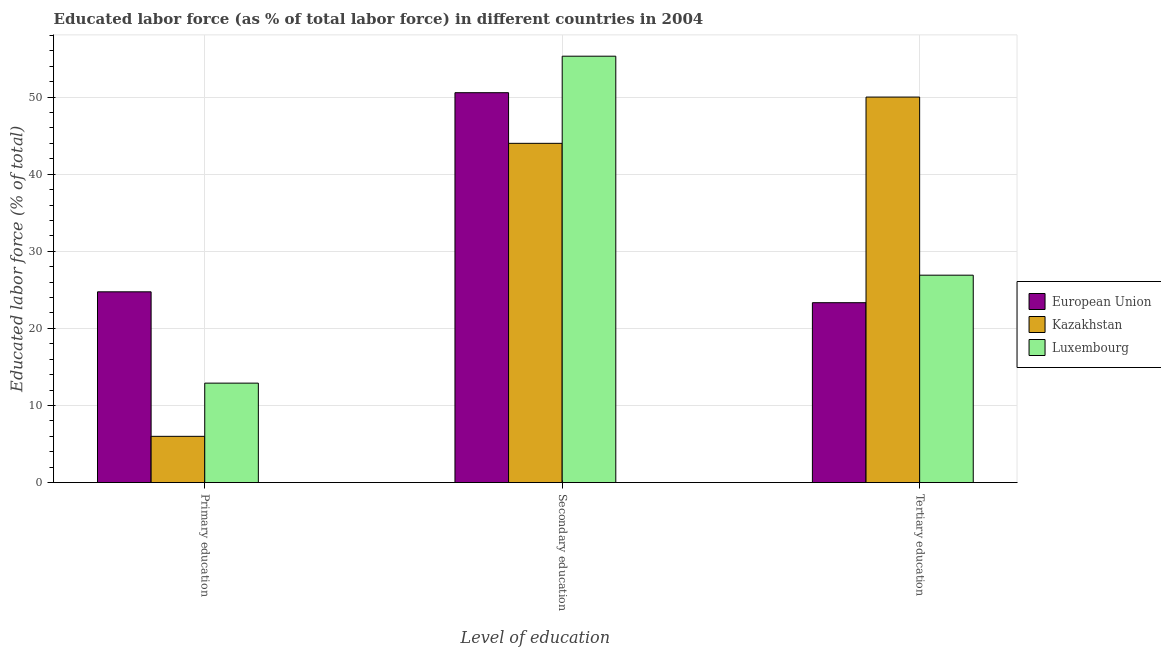How many groups of bars are there?
Offer a terse response. 3. Are the number of bars per tick equal to the number of legend labels?
Ensure brevity in your answer.  Yes. How many bars are there on the 1st tick from the right?
Provide a succinct answer. 3. What is the label of the 3rd group of bars from the left?
Keep it short and to the point. Tertiary education. Across all countries, what is the maximum percentage of labor force who received secondary education?
Make the answer very short. 55.3. Across all countries, what is the minimum percentage of labor force who received primary education?
Your answer should be compact. 6. What is the total percentage of labor force who received tertiary education in the graph?
Your response must be concise. 100.23. What is the difference between the percentage of labor force who received secondary education in European Union and that in Kazakhstan?
Provide a succinct answer. 6.57. What is the difference between the percentage of labor force who received tertiary education in Luxembourg and the percentage of labor force who received secondary education in Kazakhstan?
Offer a very short reply. -17.1. What is the average percentage of labor force who received tertiary education per country?
Your answer should be compact. 33.41. In how many countries, is the percentage of labor force who received tertiary education greater than 52 %?
Provide a succinct answer. 0. What is the ratio of the percentage of labor force who received secondary education in European Union to that in Kazakhstan?
Your answer should be very brief. 1.15. What is the difference between the highest and the second highest percentage of labor force who received primary education?
Make the answer very short. 11.84. What is the difference between the highest and the lowest percentage of labor force who received tertiary education?
Give a very brief answer. 26.67. What does the 3rd bar from the left in Tertiary education represents?
Provide a succinct answer. Luxembourg. What does the 1st bar from the right in Tertiary education represents?
Offer a terse response. Luxembourg. Is it the case that in every country, the sum of the percentage of labor force who received primary education and percentage of labor force who received secondary education is greater than the percentage of labor force who received tertiary education?
Your response must be concise. No. Are all the bars in the graph horizontal?
Provide a succinct answer. No. How many countries are there in the graph?
Offer a terse response. 3. Does the graph contain grids?
Keep it short and to the point. Yes. Where does the legend appear in the graph?
Provide a succinct answer. Center right. How are the legend labels stacked?
Ensure brevity in your answer.  Vertical. What is the title of the graph?
Your answer should be very brief. Educated labor force (as % of total labor force) in different countries in 2004. What is the label or title of the X-axis?
Your answer should be compact. Level of education. What is the label or title of the Y-axis?
Your response must be concise. Educated labor force (% of total). What is the Educated labor force (% of total) in European Union in Primary education?
Your answer should be very brief. 24.74. What is the Educated labor force (% of total) of Luxembourg in Primary education?
Ensure brevity in your answer.  12.9. What is the Educated labor force (% of total) of European Union in Secondary education?
Your response must be concise. 50.57. What is the Educated labor force (% of total) of Luxembourg in Secondary education?
Provide a short and direct response. 55.3. What is the Educated labor force (% of total) of European Union in Tertiary education?
Provide a succinct answer. 23.33. What is the Educated labor force (% of total) in Luxembourg in Tertiary education?
Your answer should be compact. 26.9. Across all Level of education, what is the maximum Educated labor force (% of total) in European Union?
Make the answer very short. 50.57. Across all Level of education, what is the maximum Educated labor force (% of total) in Kazakhstan?
Your answer should be compact. 50. Across all Level of education, what is the maximum Educated labor force (% of total) of Luxembourg?
Give a very brief answer. 55.3. Across all Level of education, what is the minimum Educated labor force (% of total) in European Union?
Your answer should be very brief. 23.33. Across all Level of education, what is the minimum Educated labor force (% of total) in Kazakhstan?
Give a very brief answer. 6. Across all Level of education, what is the minimum Educated labor force (% of total) in Luxembourg?
Ensure brevity in your answer.  12.9. What is the total Educated labor force (% of total) in European Union in the graph?
Offer a very short reply. 98.64. What is the total Educated labor force (% of total) in Luxembourg in the graph?
Offer a very short reply. 95.1. What is the difference between the Educated labor force (% of total) in European Union in Primary education and that in Secondary education?
Offer a terse response. -25.82. What is the difference between the Educated labor force (% of total) in Kazakhstan in Primary education and that in Secondary education?
Offer a very short reply. -38. What is the difference between the Educated labor force (% of total) of Luxembourg in Primary education and that in Secondary education?
Make the answer very short. -42.4. What is the difference between the Educated labor force (% of total) in European Union in Primary education and that in Tertiary education?
Your answer should be compact. 1.41. What is the difference between the Educated labor force (% of total) of Kazakhstan in Primary education and that in Tertiary education?
Offer a terse response. -44. What is the difference between the Educated labor force (% of total) in Luxembourg in Primary education and that in Tertiary education?
Your answer should be very brief. -14. What is the difference between the Educated labor force (% of total) of European Union in Secondary education and that in Tertiary education?
Provide a succinct answer. 27.23. What is the difference between the Educated labor force (% of total) of Kazakhstan in Secondary education and that in Tertiary education?
Keep it short and to the point. -6. What is the difference between the Educated labor force (% of total) in Luxembourg in Secondary education and that in Tertiary education?
Offer a very short reply. 28.4. What is the difference between the Educated labor force (% of total) of European Union in Primary education and the Educated labor force (% of total) of Kazakhstan in Secondary education?
Make the answer very short. -19.26. What is the difference between the Educated labor force (% of total) in European Union in Primary education and the Educated labor force (% of total) in Luxembourg in Secondary education?
Your answer should be very brief. -30.56. What is the difference between the Educated labor force (% of total) in Kazakhstan in Primary education and the Educated labor force (% of total) in Luxembourg in Secondary education?
Provide a short and direct response. -49.3. What is the difference between the Educated labor force (% of total) in European Union in Primary education and the Educated labor force (% of total) in Kazakhstan in Tertiary education?
Offer a terse response. -25.26. What is the difference between the Educated labor force (% of total) in European Union in Primary education and the Educated labor force (% of total) in Luxembourg in Tertiary education?
Offer a terse response. -2.16. What is the difference between the Educated labor force (% of total) of Kazakhstan in Primary education and the Educated labor force (% of total) of Luxembourg in Tertiary education?
Provide a short and direct response. -20.9. What is the difference between the Educated labor force (% of total) in European Union in Secondary education and the Educated labor force (% of total) in Kazakhstan in Tertiary education?
Offer a very short reply. 0.57. What is the difference between the Educated labor force (% of total) in European Union in Secondary education and the Educated labor force (% of total) in Luxembourg in Tertiary education?
Give a very brief answer. 23.67. What is the difference between the Educated labor force (% of total) in Kazakhstan in Secondary education and the Educated labor force (% of total) in Luxembourg in Tertiary education?
Offer a terse response. 17.1. What is the average Educated labor force (% of total) in European Union per Level of education?
Your answer should be very brief. 32.88. What is the average Educated labor force (% of total) in Kazakhstan per Level of education?
Give a very brief answer. 33.33. What is the average Educated labor force (% of total) in Luxembourg per Level of education?
Give a very brief answer. 31.7. What is the difference between the Educated labor force (% of total) of European Union and Educated labor force (% of total) of Kazakhstan in Primary education?
Keep it short and to the point. 18.74. What is the difference between the Educated labor force (% of total) in European Union and Educated labor force (% of total) in Luxembourg in Primary education?
Make the answer very short. 11.84. What is the difference between the Educated labor force (% of total) of European Union and Educated labor force (% of total) of Kazakhstan in Secondary education?
Provide a short and direct response. 6.57. What is the difference between the Educated labor force (% of total) of European Union and Educated labor force (% of total) of Luxembourg in Secondary education?
Provide a short and direct response. -4.73. What is the difference between the Educated labor force (% of total) in European Union and Educated labor force (% of total) in Kazakhstan in Tertiary education?
Provide a short and direct response. -26.67. What is the difference between the Educated labor force (% of total) of European Union and Educated labor force (% of total) of Luxembourg in Tertiary education?
Provide a short and direct response. -3.57. What is the difference between the Educated labor force (% of total) in Kazakhstan and Educated labor force (% of total) in Luxembourg in Tertiary education?
Provide a short and direct response. 23.1. What is the ratio of the Educated labor force (% of total) of European Union in Primary education to that in Secondary education?
Provide a short and direct response. 0.49. What is the ratio of the Educated labor force (% of total) of Kazakhstan in Primary education to that in Secondary education?
Your answer should be compact. 0.14. What is the ratio of the Educated labor force (% of total) in Luxembourg in Primary education to that in Secondary education?
Offer a very short reply. 0.23. What is the ratio of the Educated labor force (% of total) of European Union in Primary education to that in Tertiary education?
Offer a very short reply. 1.06. What is the ratio of the Educated labor force (% of total) in Kazakhstan in Primary education to that in Tertiary education?
Your answer should be very brief. 0.12. What is the ratio of the Educated labor force (% of total) in Luxembourg in Primary education to that in Tertiary education?
Make the answer very short. 0.48. What is the ratio of the Educated labor force (% of total) in European Union in Secondary education to that in Tertiary education?
Give a very brief answer. 2.17. What is the ratio of the Educated labor force (% of total) of Kazakhstan in Secondary education to that in Tertiary education?
Provide a short and direct response. 0.88. What is the ratio of the Educated labor force (% of total) of Luxembourg in Secondary education to that in Tertiary education?
Your answer should be very brief. 2.06. What is the difference between the highest and the second highest Educated labor force (% of total) in European Union?
Provide a short and direct response. 25.82. What is the difference between the highest and the second highest Educated labor force (% of total) of Luxembourg?
Make the answer very short. 28.4. What is the difference between the highest and the lowest Educated labor force (% of total) of European Union?
Keep it short and to the point. 27.23. What is the difference between the highest and the lowest Educated labor force (% of total) in Luxembourg?
Your answer should be very brief. 42.4. 